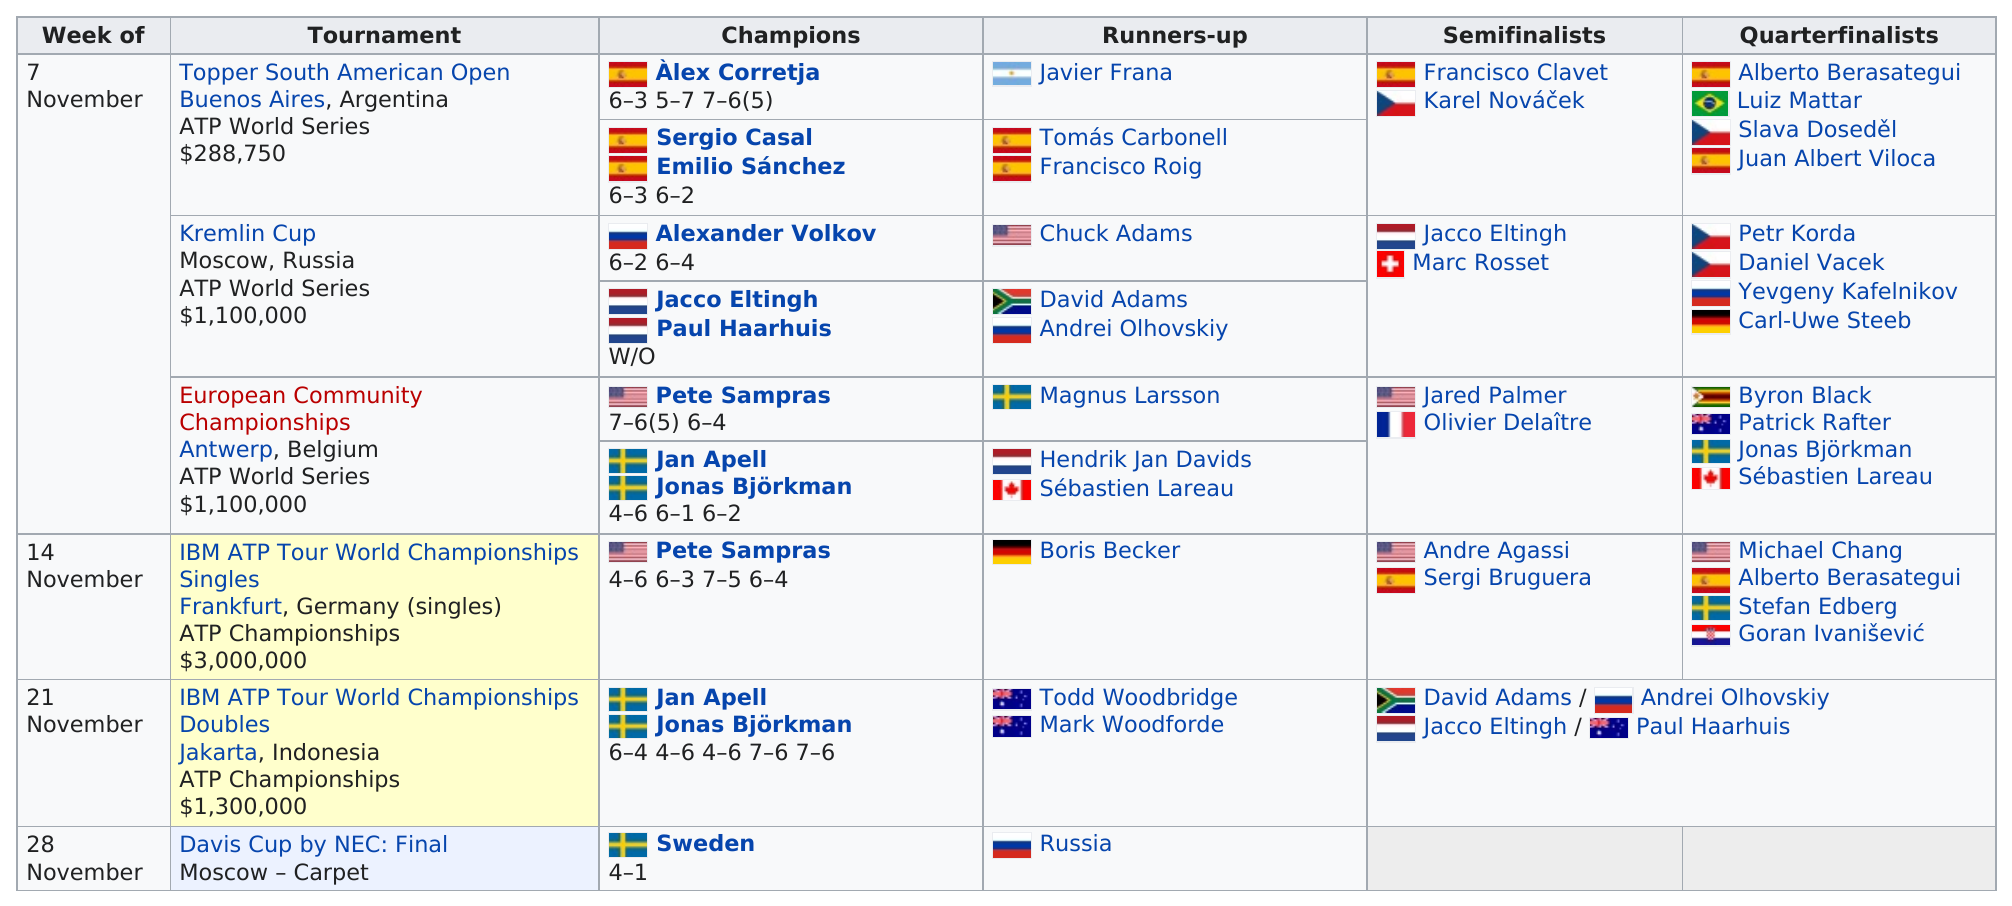Mention a couple of crucial points in this snapshot. Pete Sampras was the first American to become a champion. There are a total of 6 Americans participating in the tournaments. The first week of the tournament will commence on 7 November. Sébastien Lareau is the only Canadian participating in the tournaments. Out of all the countries that have them, Russia has the least number of champions. 